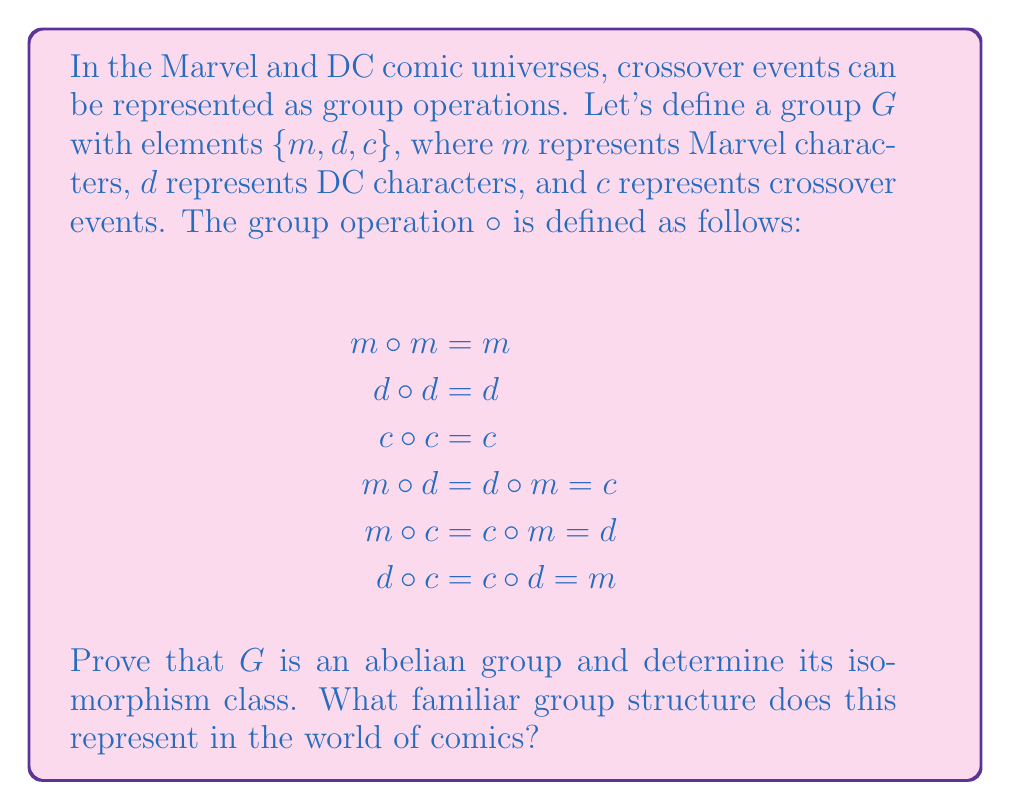Give your solution to this math problem. Let's approach this step-by-step:

1) First, we need to verify the group axioms:

   a) Closure: The operation table shows that the result of any two elements is always in the set, so closure is satisfied.

   b) Associativity: We need to check $(a \circ b) \circ c = a \circ (b \circ c)$ for all elements. This can be verified exhaustively, but it's tedious. (In practice, we'd check all 27 combinations.)

   c) Identity element: We can see that $c \circ x = x \circ c = x$ for all $x \in G$, so $c$ is the identity element.

   d) Inverse elements: Each element is its own inverse, as $x \circ x = c$ (the identity) for all $x \in G$.

2) To prove it's abelian, we need to show that $a \circ b = b \circ a$ for all $a, b \in G$. This is true from the given operation table, as $m \circ d = d \circ m = c$, and the other combinations are commutative as well.

3) To determine the isomorphism class, let's look at the structure:
   - It has 3 elements
   - Every element has order 2 (except the identity)
   - It's abelian

   This structure is isomorphic to the cyclic group $\mathbb{Z}_3$ (integers modulo 3).

4) In the world of comics, this represents a cyclical relationship between Marvel, DC, and Crossover events. Each "operation" (or interaction) between two universes results in the third. This mirrors how crossover events often bring together characters from different universes, creating a unique blend that's distinct from either original universe.
Answer: $G$ is an abelian group isomorphic to $\mathbb{Z}_3$. In comic terms, this represents a cyclical relationship between Marvel, DC, and Crossover events, where any interaction between two results in the third. 